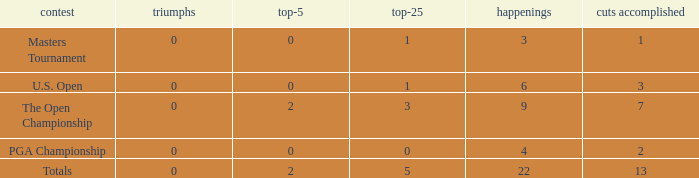How many total cuts were made in events with more than 0 wins and exactly 0 top-5s? 0.0. 